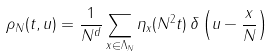Convert formula to latex. <formula><loc_0><loc_0><loc_500><loc_500>\rho _ { N } ( t , u ) = \frac { 1 } { N ^ { d } } \sum _ { x \in \Lambda _ { N } } \eta _ { x } ( N ^ { 2 } t ) \, \delta \left ( u - \frac { x } { N } \right )</formula> 